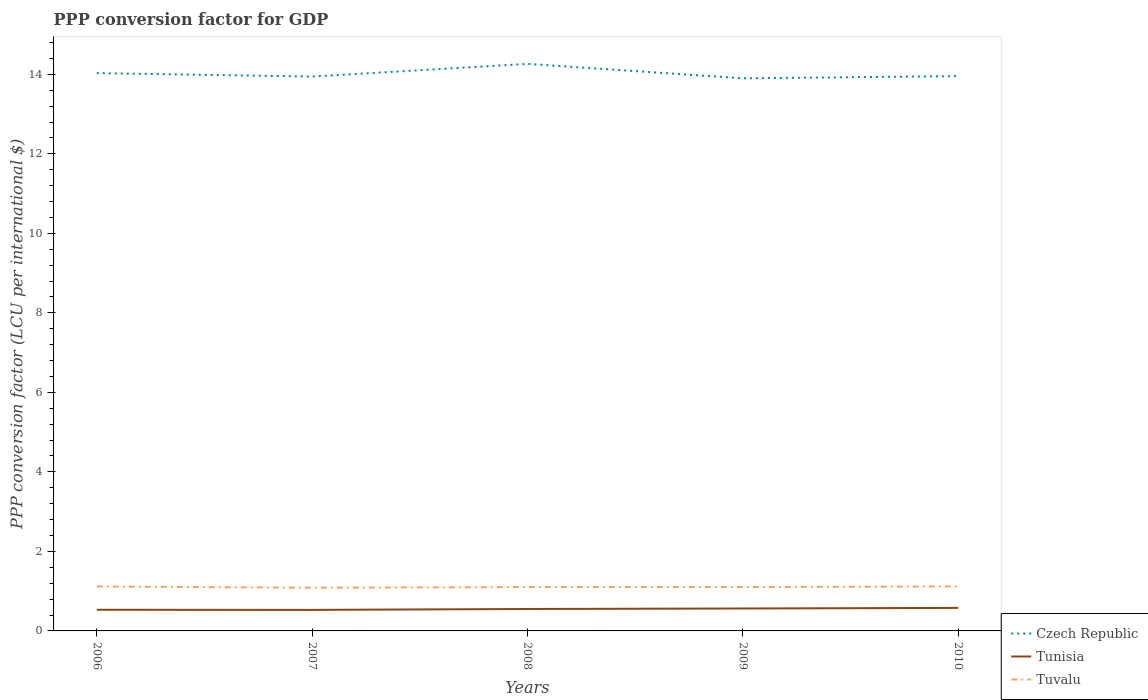How many different coloured lines are there?
Offer a very short reply. 3. Across all years, what is the maximum PPP conversion factor for GDP in Tunisia?
Make the answer very short. 0.53. In which year was the PPP conversion factor for GDP in Tuvalu maximum?
Your answer should be compact. 2007. What is the total PPP conversion factor for GDP in Czech Republic in the graph?
Offer a very short reply. 0.36. What is the difference between the highest and the second highest PPP conversion factor for GDP in Tuvalu?
Your response must be concise. 0.03. What is the difference between the highest and the lowest PPP conversion factor for GDP in Czech Republic?
Keep it short and to the point. 2. How many lines are there?
Offer a terse response. 3. What is the difference between two consecutive major ticks on the Y-axis?
Your answer should be compact. 2. Are the values on the major ticks of Y-axis written in scientific E-notation?
Your answer should be compact. No. Where does the legend appear in the graph?
Keep it short and to the point. Bottom right. What is the title of the graph?
Your response must be concise. PPP conversion factor for GDP. What is the label or title of the Y-axis?
Your answer should be very brief. PPP conversion factor (LCU per international $). What is the PPP conversion factor (LCU per international $) of Czech Republic in 2006?
Offer a terse response. 14.03. What is the PPP conversion factor (LCU per international $) of Tunisia in 2006?
Offer a very short reply. 0.53. What is the PPP conversion factor (LCU per international $) of Tuvalu in 2006?
Your answer should be compact. 1.12. What is the PPP conversion factor (LCU per international $) of Czech Republic in 2007?
Your answer should be very brief. 13.94. What is the PPP conversion factor (LCU per international $) in Tunisia in 2007?
Your answer should be very brief. 0.53. What is the PPP conversion factor (LCU per international $) of Tuvalu in 2007?
Your answer should be compact. 1.09. What is the PPP conversion factor (LCU per international $) in Czech Republic in 2008?
Make the answer very short. 14.26. What is the PPP conversion factor (LCU per international $) in Tunisia in 2008?
Your answer should be compact. 0.55. What is the PPP conversion factor (LCU per international $) of Tuvalu in 2008?
Give a very brief answer. 1.1. What is the PPP conversion factor (LCU per international $) in Czech Republic in 2009?
Give a very brief answer. 13.9. What is the PPP conversion factor (LCU per international $) of Tunisia in 2009?
Your response must be concise. 0.56. What is the PPP conversion factor (LCU per international $) of Tuvalu in 2009?
Provide a succinct answer. 1.1. What is the PPP conversion factor (LCU per international $) of Czech Republic in 2010?
Provide a short and direct response. 13.95. What is the PPP conversion factor (LCU per international $) in Tunisia in 2010?
Provide a short and direct response. 0.58. What is the PPP conversion factor (LCU per international $) in Tuvalu in 2010?
Your response must be concise. 1.12. Across all years, what is the maximum PPP conversion factor (LCU per international $) in Czech Republic?
Your response must be concise. 14.26. Across all years, what is the maximum PPP conversion factor (LCU per international $) of Tunisia?
Ensure brevity in your answer.  0.58. Across all years, what is the maximum PPP conversion factor (LCU per international $) of Tuvalu?
Provide a short and direct response. 1.12. Across all years, what is the minimum PPP conversion factor (LCU per international $) in Czech Republic?
Your answer should be compact. 13.9. Across all years, what is the minimum PPP conversion factor (LCU per international $) of Tunisia?
Give a very brief answer. 0.53. Across all years, what is the minimum PPP conversion factor (LCU per international $) of Tuvalu?
Ensure brevity in your answer.  1.09. What is the total PPP conversion factor (LCU per international $) of Czech Republic in the graph?
Keep it short and to the point. 70.09. What is the total PPP conversion factor (LCU per international $) of Tunisia in the graph?
Make the answer very short. 2.76. What is the total PPP conversion factor (LCU per international $) in Tuvalu in the graph?
Offer a terse response. 5.53. What is the difference between the PPP conversion factor (LCU per international $) in Czech Republic in 2006 and that in 2007?
Make the answer very short. 0.09. What is the difference between the PPP conversion factor (LCU per international $) in Tunisia in 2006 and that in 2007?
Your response must be concise. 0. What is the difference between the PPP conversion factor (LCU per international $) of Tuvalu in 2006 and that in 2007?
Offer a terse response. 0.03. What is the difference between the PPP conversion factor (LCU per international $) of Czech Republic in 2006 and that in 2008?
Keep it short and to the point. -0.23. What is the difference between the PPP conversion factor (LCU per international $) of Tunisia in 2006 and that in 2008?
Offer a terse response. -0.02. What is the difference between the PPP conversion factor (LCU per international $) in Tuvalu in 2006 and that in 2008?
Your answer should be very brief. 0.01. What is the difference between the PPP conversion factor (LCU per international $) of Czech Republic in 2006 and that in 2009?
Provide a short and direct response. 0.13. What is the difference between the PPP conversion factor (LCU per international $) in Tunisia in 2006 and that in 2009?
Offer a terse response. -0.03. What is the difference between the PPP conversion factor (LCU per international $) of Tuvalu in 2006 and that in 2009?
Keep it short and to the point. 0.01. What is the difference between the PPP conversion factor (LCU per international $) in Czech Republic in 2006 and that in 2010?
Your answer should be compact. 0.08. What is the difference between the PPP conversion factor (LCU per international $) in Tunisia in 2006 and that in 2010?
Keep it short and to the point. -0.05. What is the difference between the PPP conversion factor (LCU per international $) in Tuvalu in 2006 and that in 2010?
Offer a terse response. -0. What is the difference between the PPP conversion factor (LCU per international $) of Czech Republic in 2007 and that in 2008?
Ensure brevity in your answer.  -0.32. What is the difference between the PPP conversion factor (LCU per international $) of Tunisia in 2007 and that in 2008?
Ensure brevity in your answer.  -0.02. What is the difference between the PPP conversion factor (LCU per international $) in Tuvalu in 2007 and that in 2008?
Offer a terse response. -0.02. What is the difference between the PPP conversion factor (LCU per international $) of Czech Republic in 2007 and that in 2009?
Keep it short and to the point. 0.04. What is the difference between the PPP conversion factor (LCU per international $) in Tunisia in 2007 and that in 2009?
Offer a very short reply. -0.04. What is the difference between the PPP conversion factor (LCU per international $) of Tuvalu in 2007 and that in 2009?
Offer a very short reply. -0.02. What is the difference between the PPP conversion factor (LCU per international $) in Czech Republic in 2007 and that in 2010?
Provide a succinct answer. -0.01. What is the difference between the PPP conversion factor (LCU per international $) of Tunisia in 2007 and that in 2010?
Give a very brief answer. -0.05. What is the difference between the PPP conversion factor (LCU per international $) in Tuvalu in 2007 and that in 2010?
Provide a short and direct response. -0.03. What is the difference between the PPP conversion factor (LCU per international $) in Czech Republic in 2008 and that in 2009?
Your answer should be very brief. 0.36. What is the difference between the PPP conversion factor (LCU per international $) in Tunisia in 2008 and that in 2009?
Give a very brief answer. -0.01. What is the difference between the PPP conversion factor (LCU per international $) in Tuvalu in 2008 and that in 2009?
Your answer should be very brief. 0. What is the difference between the PPP conversion factor (LCU per international $) in Czech Republic in 2008 and that in 2010?
Ensure brevity in your answer.  0.31. What is the difference between the PPP conversion factor (LCU per international $) of Tunisia in 2008 and that in 2010?
Your response must be concise. -0.03. What is the difference between the PPP conversion factor (LCU per international $) in Tuvalu in 2008 and that in 2010?
Your answer should be compact. -0.01. What is the difference between the PPP conversion factor (LCU per international $) in Czech Republic in 2009 and that in 2010?
Provide a short and direct response. -0.05. What is the difference between the PPP conversion factor (LCU per international $) of Tunisia in 2009 and that in 2010?
Provide a succinct answer. -0.01. What is the difference between the PPP conversion factor (LCU per international $) of Tuvalu in 2009 and that in 2010?
Offer a very short reply. -0.02. What is the difference between the PPP conversion factor (LCU per international $) in Czech Republic in 2006 and the PPP conversion factor (LCU per international $) in Tunisia in 2007?
Offer a terse response. 13.5. What is the difference between the PPP conversion factor (LCU per international $) in Czech Republic in 2006 and the PPP conversion factor (LCU per international $) in Tuvalu in 2007?
Make the answer very short. 12.94. What is the difference between the PPP conversion factor (LCU per international $) of Tunisia in 2006 and the PPP conversion factor (LCU per international $) of Tuvalu in 2007?
Give a very brief answer. -0.56. What is the difference between the PPP conversion factor (LCU per international $) of Czech Republic in 2006 and the PPP conversion factor (LCU per international $) of Tunisia in 2008?
Offer a very short reply. 13.48. What is the difference between the PPP conversion factor (LCU per international $) of Czech Republic in 2006 and the PPP conversion factor (LCU per international $) of Tuvalu in 2008?
Make the answer very short. 12.93. What is the difference between the PPP conversion factor (LCU per international $) of Tunisia in 2006 and the PPP conversion factor (LCU per international $) of Tuvalu in 2008?
Your response must be concise. -0.57. What is the difference between the PPP conversion factor (LCU per international $) of Czech Republic in 2006 and the PPP conversion factor (LCU per international $) of Tunisia in 2009?
Keep it short and to the point. 13.46. What is the difference between the PPP conversion factor (LCU per international $) in Czech Republic in 2006 and the PPP conversion factor (LCU per international $) in Tuvalu in 2009?
Offer a very short reply. 12.93. What is the difference between the PPP conversion factor (LCU per international $) in Tunisia in 2006 and the PPP conversion factor (LCU per international $) in Tuvalu in 2009?
Your answer should be compact. -0.57. What is the difference between the PPP conversion factor (LCU per international $) in Czech Republic in 2006 and the PPP conversion factor (LCU per international $) in Tunisia in 2010?
Make the answer very short. 13.45. What is the difference between the PPP conversion factor (LCU per international $) in Czech Republic in 2006 and the PPP conversion factor (LCU per international $) in Tuvalu in 2010?
Ensure brevity in your answer.  12.91. What is the difference between the PPP conversion factor (LCU per international $) in Tunisia in 2006 and the PPP conversion factor (LCU per international $) in Tuvalu in 2010?
Your answer should be compact. -0.59. What is the difference between the PPP conversion factor (LCU per international $) in Czech Republic in 2007 and the PPP conversion factor (LCU per international $) in Tunisia in 2008?
Ensure brevity in your answer.  13.39. What is the difference between the PPP conversion factor (LCU per international $) in Czech Republic in 2007 and the PPP conversion factor (LCU per international $) in Tuvalu in 2008?
Keep it short and to the point. 12.84. What is the difference between the PPP conversion factor (LCU per international $) of Tunisia in 2007 and the PPP conversion factor (LCU per international $) of Tuvalu in 2008?
Make the answer very short. -0.57. What is the difference between the PPP conversion factor (LCU per international $) of Czech Republic in 2007 and the PPP conversion factor (LCU per international $) of Tunisia in 2009?
Provide a short and direct response. 13.38. What is the difference between the PPP conversion factor (LCU per international $) in Czech Republic in 2007 and the PPP conversion factor (LCU per international $) in Tuvalu in 2009?
Provide a succinct answer. 12.84. What is the difference between the PPP conversion factor (LCU per international $) of Tunisia in 2007 and the PPP conversion factor (LCU per international $) of Tuvalu in 2009?
Make the answer very short. -0.57. What is the difference between the PPP conversion factor (LCU per international $) in Czech Republic in 2007 and the PPP conversion factor (LCU per international $) in Tunisia in 2010?
Offer a very short reply. 13.37. What is the difference between the PPP conversion factor (LCU per international $) in Czech Republic in 2007 and the PPP conversion factor (LCU per international $) in Tuvalu in 2010?
Your answer should be very brief. 12.83. What is the difference between the PPP conversion factor (LCU per international $) in Tunisia in 2007 and the PPP conversion factor (LCU per international $) in Tuvalu in 2010?
Provide a short and direct response. -0.59. What is the difference between the PPP conversion factor (LCU per international $) in Czech Republic in 2008 and the PPP conversion factor (LCU per international $) in Tunisia in 2009?
Offer a terse response. 13.7. What is the difference between the PPP conversion factor (LCU per international $) in Czech Republic in 2008 and the PPP conversion factor (LCU per international $) in Tuvalu in 2009?
Your response must be concise. 13.16. What is the difference between the PPP conversion factor (LCU per international $) in Tunisia in 2008 and the PPP conversion factor (LCU per international $) in Tuvalu in 2009?
Offer a terse response. -0.55. What is the difference between the PPP conversion factor (LCU per international $) of Czech Republic in 2008 and the PPP conversion factor (LCU per international $) of Tunisia in 2010?
Ensure brevity in your answer.  13.68. What is the difference between the PPP conversion factor (LCU per international $) of Czech Republic in 2008 and the PPP conversion factor (LCU per international $) of Tuvalu in 2010?
Your answer should be very brief. 13.14. What is the difference between the PPP conversion factor (LCU per international $) of Tunisia in 2008 and the PPP conversion factor (LCU per international $) of Tuvalu in 2010?
Your response must be concise. -0.57. What is the difference between the PPP conversion factor (LCU per international $) of Czech Republic in 2009 and the PPP conversion factor (LCU per international $) of Tunisia in 2010?
Provide a succinct answer. 13.32. What is the difference between the PPP conversion factor (LCU per international $) in Czech Republic in 2009 and the PPP conversion factor (LCU per international $) in Tuvalu in 2010?
Your answer should be very brief. 12.78. What is the difference between the PPP conversion factor (LCU per international $) in Tunisia in 2009 and the PPP conversion factor (LCU per international $) in Tuvalu in 2010?
Give a very brief answer. -0.55. What is the average PPP conversion factor (LCU per international $) in Czech Republic per year?
Your answer should be very brief. 14.02. What is the average PPP conversion factor (LCU per international $) of Tunisia per year?
Ensure brevity in your answer.  0.55. What is the average PPP conversion factor (LCU per international $) in Tuvalu per year?
Offer a terse response. 1.11. In the year 2006, what is the difference between the PPP conversion factor (LCU per international $) in Czech Republic and PPP conversion factor (LCU per international $) in Tunisia?
Make the answer very short. 13.5. In the year 2006, what is the difference between the PPP conversion factor (LCU per international $) of Czech Republic and PPP conversion factor (LCU per international $) of Tuvalu?
Offer a terse response. 12.91. In the year 2006, what is the difference between the PPP conversion factor (LCU per international $) of Tunisia and PPP conversion factor (LCU per international $) of Tuvalu?
Offer a very short reply. -0.59. In the year 2007, what is the difference between the PPP conversion factor (LCU per international $) in Czech Republic and PPP conversion factor (LCU per international $) in Tunisia?
Your response must be concise. 13.41. In the year 2007, what is the difference between the PPP conversion factor (LCU per international $) of Czech Republic and PPP conversion factor (LCU per international $) of Tuvalu?
Make the answer very short. 12.86. In the year 2007, what is the difference between the PPP conversion factor (LCU per international $) of Tunisia and PPP conversion factor (LCU per international $) of Tuvalu?
Your answer should be very brief. -0.56. In the year 2008, what is the difference between the PPP conversion factor (LCU per international $) of Czech Republic and PPP conversion factor (LCU per international $) of Tunisia?
Offer a very short reply. 13.71. In the year 2008, what is the difference between the PPP conversion factor (LCU per international $) of Czech Republic and PPP conversion factor (LCU per international $) of Tuvalu?
Your answer should be very brief. 13.16. In the year 2008, what is the difference between the PPP conversion factor (LCU per international $) of Tunisia and PPP conversion factor (LCU per international $) of Tuvalu?
Your answer should be compact. -0.55. In the year 2009, what is the difference between the PPP conversion factor (LCU per international $) of Czech Republic and PPP conversion factor (LCU per international $) of Tunisia?
Keep it short and to the point. 13.33. In the year 2009, what is the difference between the PPP conversion factor (LCU per international $) of Czech Republic and PPP conversion factor (LCU per international $) of Tuvalu?
Keep it short and to the point. 12.8. In the year 2009, what is the difference between the PPP conversion factor (LCU per international $) in Tunisia and PPP conversion factor (LCU per international $) in Tuvalu?
Offer a very short reply. -0.54. In the year 2010, what is the difference between the PPP conversion factor (LCU per international $) of Czech Republic and PPP conversion factor (LCU per international $) of Tunisia?
Your response must be concise. 13.37. In the year 2010, what is the difference between the PPP conversion factor (LCU per international $) of Czech Republic and PPP conversion factor (LCU per international $) of Tuvalu?
Give a very brief answer. 12.84. In the year 2010, what is the difference between the PPP conversion factor (LCU per international $) in Tunisia and PPP conversion factor (LCU per international $) in Tuvalu?
Ensure brevity in your answer.  -0.54. What is the ratio of the PPP conversion factor (LCU per international $) of Czech Republic in 2006 to that in 2007?
Offer a very short reply. 1.01. What is the ratio of the PPP conversion factor (LCU per international $) of Tunisia in 2006 to that in 2007?
Provide a short and direct response. 1.01. What is the ratio of the PPP conversion factor (LCU per international $) of Tuvalu in 2006 to that in 2007?
Keep it short and to the point. 1.03. What is the ratio of the PPP conversion factor (LCU per international $) in Czech Republic in 2006 to that in 2008?
Provide a succinct answer. 0.98. What is the ratio of the PPP conversion factor (LCU per international $) of Tuvalu in 2006 to that in 2008?
Offer a terse response. 1.01. What is the ratio of the PPP conversion factor (LCU per international $) of Czech Republic in 2006 to that in 2009?
Offer a terse response. 1.01. What is the ratio of the PPP conversion factor (LCU per international $) in Tunisia in 2006 to that in 2009?
Your answer should be very brief. 0.94. What is the ratio of the PPP conversion factor (LCU per international $) of Tuvalu in 2006 to that in 2009?
Your response must be concise. 1.01. What is the ratio of the PPP conversion factor (LCU per international $) of Czech Republic in 2006 to that in 2010?
Offer a terse response. 1.01. What is the ratio of the PPP conversion factor (LCU per international $) in Tunisia in 2006 to that in 2010?
Your answer should be compact. 0.92. What is the ratio of the PPP conversion factor (LCU per international $) of Czech Republic in 2007 to that in 2008?
Offer a terse response. 0.98. What is the ratio of the PPP conversion factor (LCU per international $) of Tunisia in 2007 to that in 2008?
Your response must be concise. 0.96. What is the ratio of the PPP conversion factor (LCU per international $) of Tuvalu in 2007 to that in 2008?
Offer a terse response. 0.98. What is the ratio of the PPP conversion factor (LCU per international $) in Czech Republic in 2007 to that in 2009?
Provide a short and direct response. 1. What is the ratio of the PPP conversion factor (LCU per international $) in Tunisia in 2007 to that in 2009?
Ensure brevity in your answer.  0.94. What is the ratio of the PPP conversion factor (LCU per international $) of Tuvalu in 2007 to that in 2009?
Your answer should be very brief. 0.99. What is the ratio of the PPP conversion factor (LCU per international $) of Czech Republic in 2007 to that in 2010?
Give a very brief answer. 1. What is the ratio of the PPP conversion factor (LCU per international $) of Tunisia in 2007 to that in 2010?
Keep it short and to the point. 0.91. What is the ratio of the PPP conversion factor (LCU per international $) of Tuvalu in 2007 to that in 2010?
Offer a terse response. 0.97. What is the ratio of the PPP conversion factor (LCU per international $) of Czech Republic in 2008 to that in 2009?
Your response must be concise. 1.03. What is the ratio of the PPP conversion factor (LCU per international $) of Tunisia in 2008 to that in 2009?
Your answer should be compact. 0.98. What is the ratio of the PPP conversion factor (LCU per international $) of Tuvalu in 2008 to that in 2009?
Ensure brevity in your answer.  1. What is the ratio of the PPP conversion factor (LCU per international $) in Czech Republic in 2008 to that in 2010?
Your answer should be compact. 1.02. What is the ratio of the PPP conversion factor (LCU per international $) of Tunisia in 2008 to that in 2010?
Offer a very short reply. 0.95. What is the ratio of the PPP conversion factor (LCU per international $) in Tuvalu in 2009 to that in 2010?
Your answer should be compact. 0.99. What is the difference between the highest and the second highest PPP conversion factor (LCU per international $) of Czech Republic?
Provide a short and direct response. 0.23. What is the difference between the highest and the second highest PPP conversion factor (LCU per international $) in Tunisia?
Give a very brief answer. 0.01. What is the difference between the highest and the lowest PPP conversion factor (LCU per international $) in Czech Republic?
Ensure brevity in your answer.  0.36. What is the difference between the highest and the lowest PPP conversion factor (LCU per international $) in Tunisia?
Your response must be concise. 0.05. What is the difference between the highest and the lowest PPP conversion factor (LCU per international $) of Tuvalu?
Your answer should be compact. 0.03. 